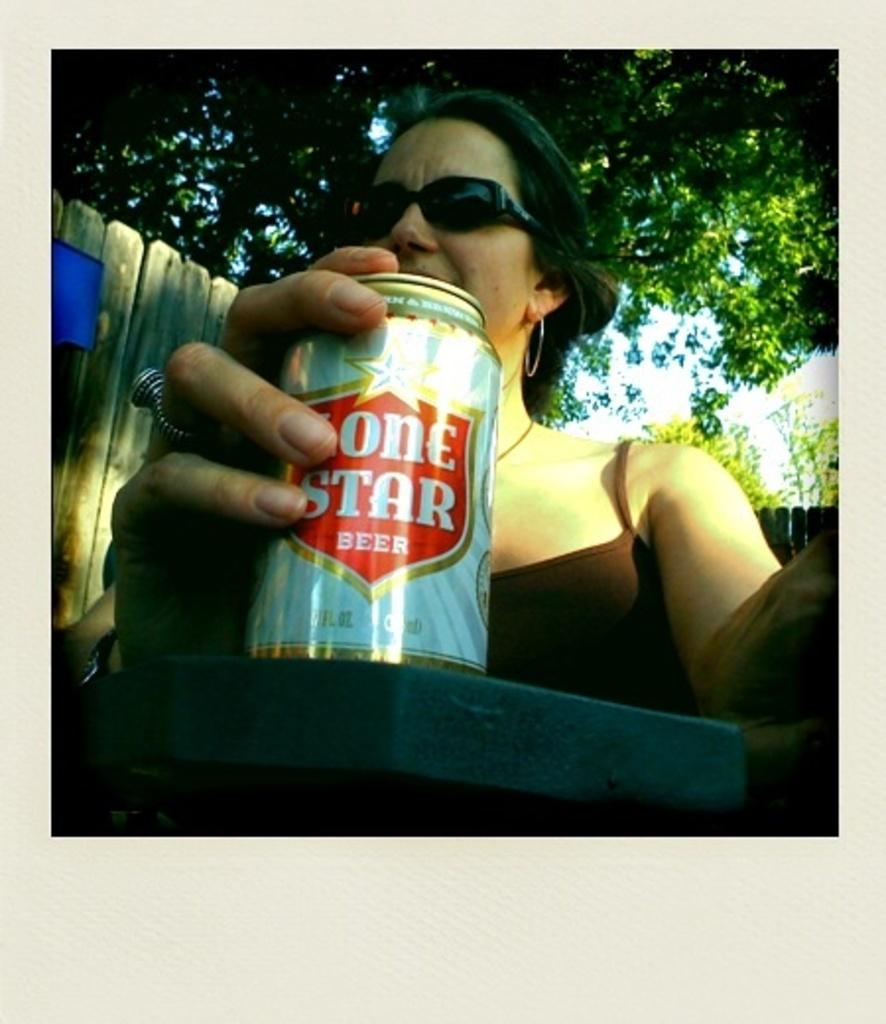Who is present in the image? There is a woman in the image. What is the woman holding in the image? The woman is holding a tin. What protective gear is the woman wearing? The woman is wearing goggles. What can be seen in the background of the image? There are trees and the sky visible in the background of the image. What type of thread is being used to sew the stars in the image? There are no stars or thread present in the image. 